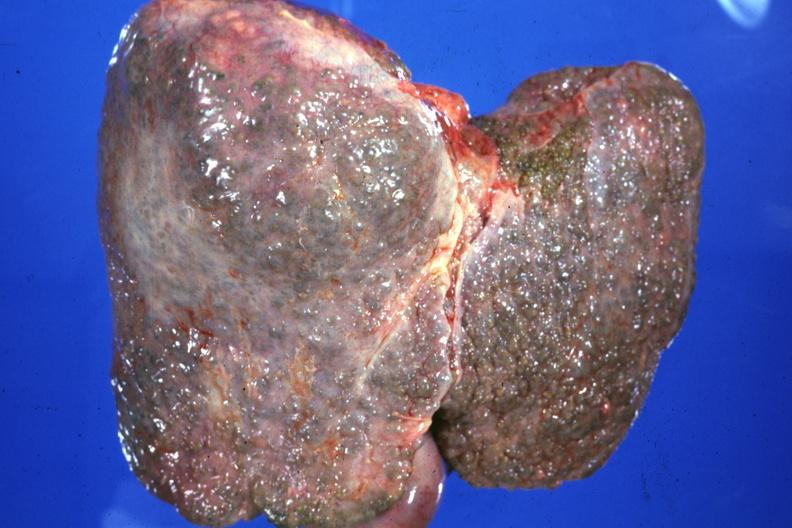what is present?
Answer the question using a single word or phrase. Liver 